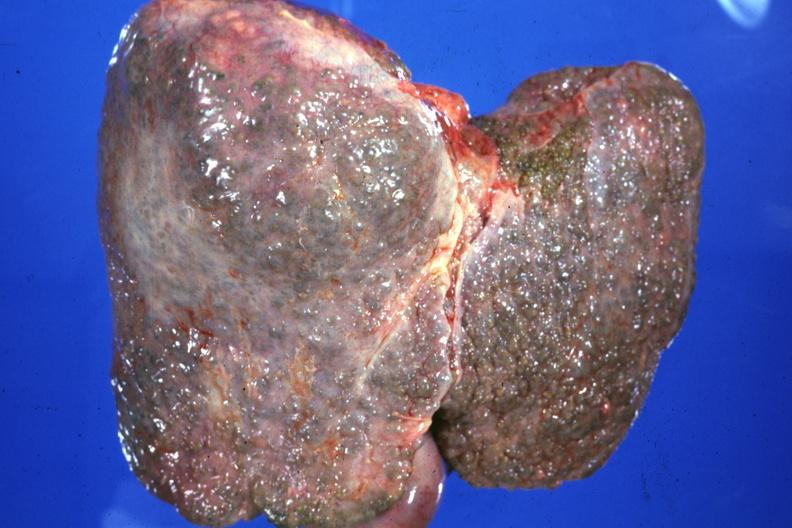what is present?
Answer the question using a single word or phrase. Liver 